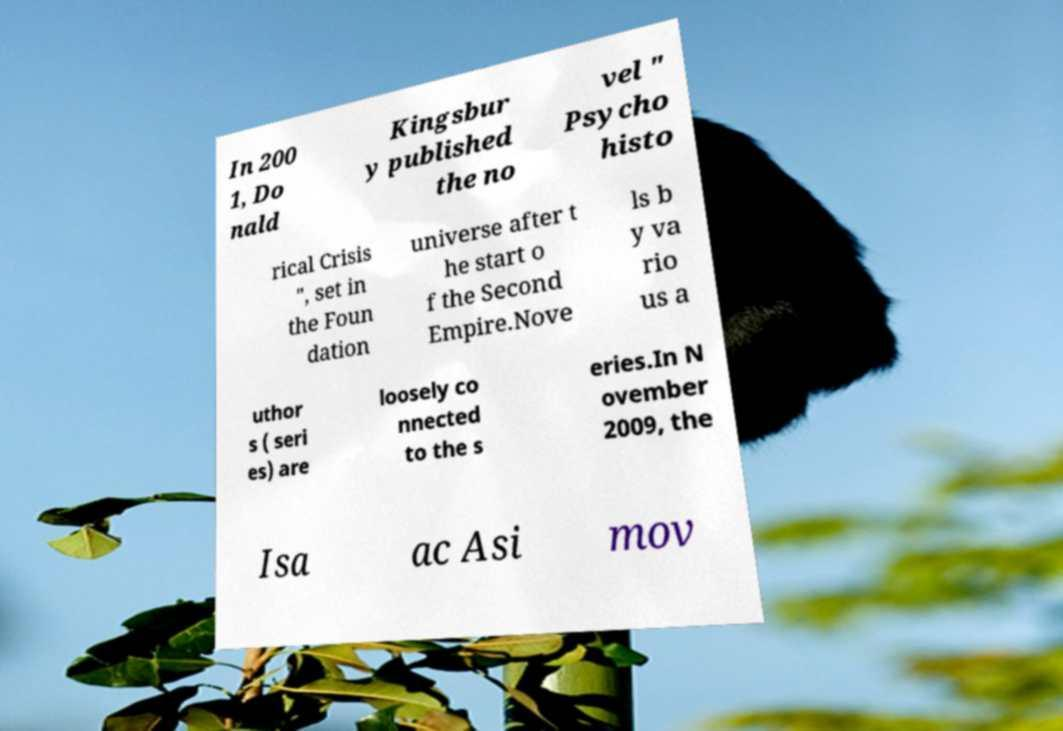Please identify and transcribe the text found in this image. In 200 1, Do nald Kingsbur y published the no vel " Psycho histo rical Crisis ", set in the Foun dation universe after t he start o f the Second Empire.Nove ls b y va rio us a uthor s ( seri es) are loosely co nnected to the s eries.In N ovember 2009, the Isa ac Asi mov 